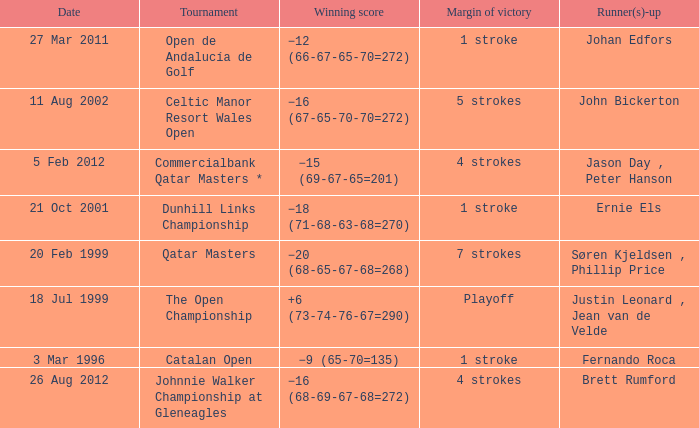What is the winning score for the runner-up Ernie Els? −18 (71-68-63-68=270). 